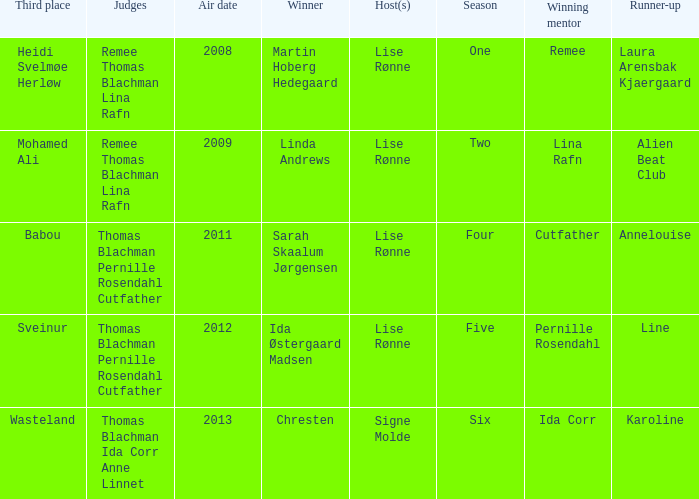Who won third place in season four? Babou. Would you mind parsing the complete table? {'header': ['Third place', 'Judges', 'Air date', 'Winner', 'Host(s)', 'Season', 'Winning mentor', 'Runner-up'], 'rows': [['Heidi Svelmøe Herløw', 'Remee Thomas Blachman Lina Rafn', '2008', 'Martin Hoberg Hedegaard', 'Lise Rønne', 'One', 'Remee', 'Laura Arensbak Kjaergaard'], ['Mohamed Ali', 'Remee Thomas Blachman Lina Rafn', '2009', 'Linda Andrews', 'Lise Rønne', 'Two', 'Lina Rafn', 'Alien Beat Club'], ['Babou', 'Thomas Blachman Pernille Rosendahl Cutfather', '2011', 'Sarah Skaalum Jørgensen', 'Lise Rønne', 'Four', 'Cutfather', 'Annelouise'], ['Sveinur', 'Thomas Blachman Pernille Rosendahl Cutfather', '2012', 'Ida Østergaard Madsen', 'Lise Rønne', 'Five', 'Pernille Rosendahl', 'Line'], ['Wasteland', 'Thomas Blachman Ida Corr Anne Linnet', '2013', 'Chresten', 'Signe Molde', 'Six', 'Ida Corr', 'Karoline']]} 